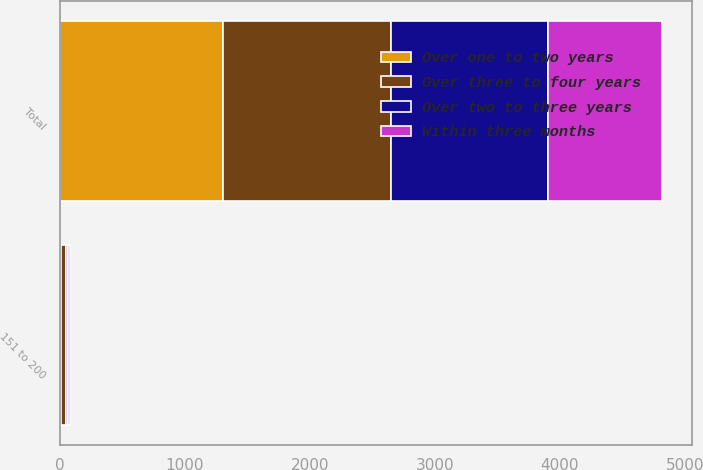Convert chart to OTSL. <chart><loc_0><loc_0><loc_500><loc_500><stacked_bar_chart><ecel><fcel>151 to 200<fcel>Total<nl><fcel>Over two to three years<fcel>18.4<fcel>1254.3<nl><fcel>Within three months<fcel>15.2<fcel>912.5<nl><fcel>Over one to two years<fcel>7.1<fcel>1306.7<nl><fcel>Over three to four years<fcel>40.3<fcel>1341<nl></chart> 